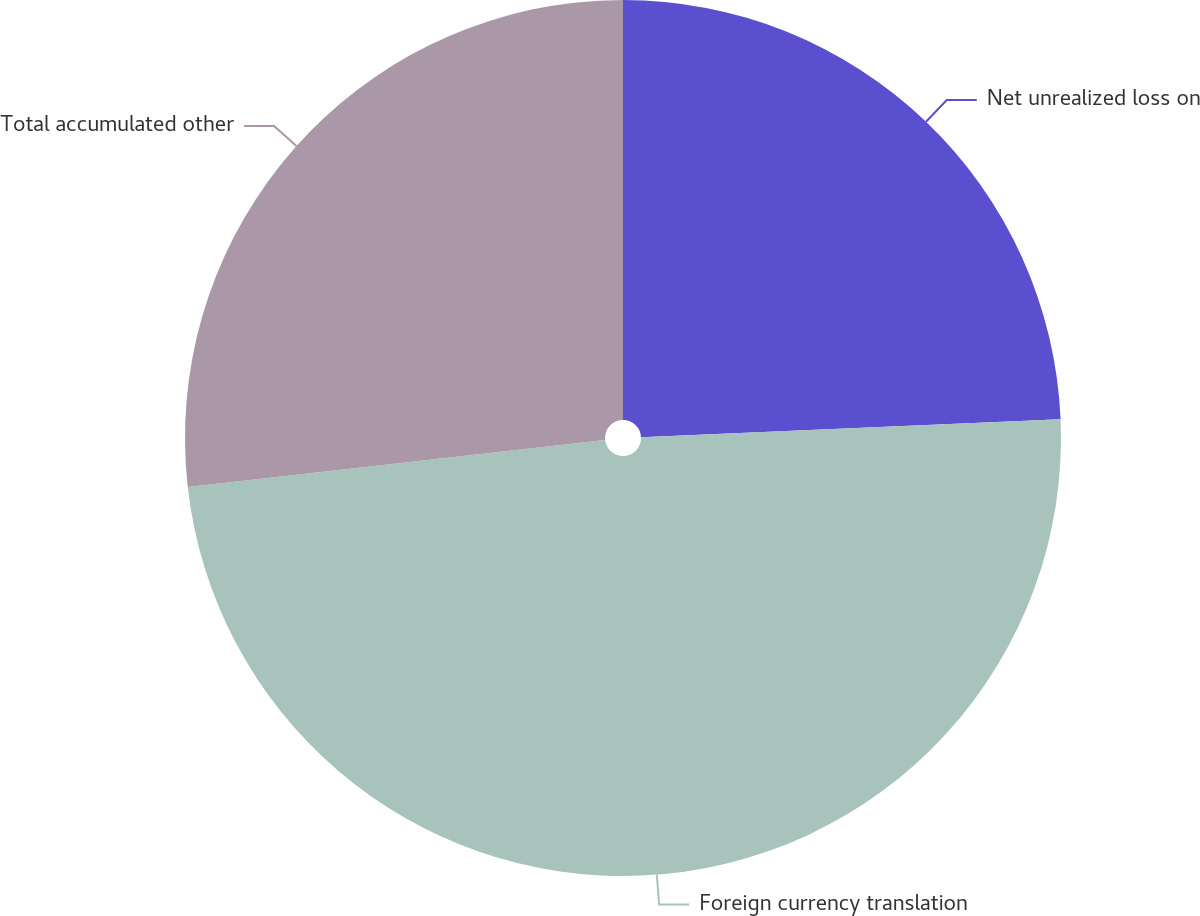Convert chart to OTSL. <chart><loc_0><loc_0><loc_500><loc_500><pie_chart><fcel>Net unrealized loss on<fcel>Foreign currency translation<fcel>Total accumulated other<nl><fcel>24.32%<fcel>48.9%<fcel>26.78%<nl></chart> 